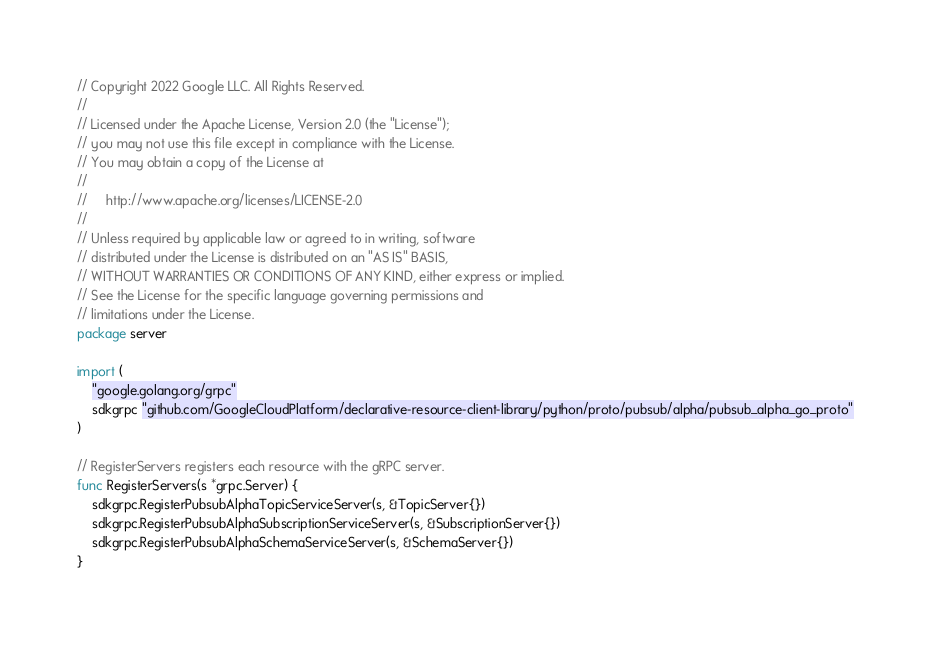Convert code to text. <code><loc_0><loc_0><loc_500><loc_500><_Go_>// Copyright 2022 Google LLC. All Rights Reserved.
// 
// Licensed under the Apache License, Version 2.0 (the "License");
// you may not use this file except in compliance with the License.
// You may obtain a copy of the License at
// 
//     http://www.apache.org/licenses/LICENSE-2.0
// 
// Unless required by applicable law or agreed to in writing, software
// distributed under the License is distributed on an "AS IS" BASIS,
// WITHOUT WARRANTIES OR CONDITIONS OF ANY KIND, either express or implied.
// See the License for the specific language governing permissions and
// limitations under the License.
package server

import (
	"google.golang.org/grpc"
	sdkgrpc "github.com/GoogleCloudPlatform/declarative-resource-client-library/python/proto/pubsub/alpha/pubsub_alpha_go_proto"
)

// RegisterServers registers each resource with the gRPC server.
func RegisterServers(s *grpc.Server) {
	sdkgrpc.RegisterPubsubAlphaTopicServiceServer(s, &TopicServer{})
	sdkgrpc.RegisterPubsubAlphaSubscriptionServiceServer(s, &SubscriptionServer{})
	sdkgrpc.RegisterPubsubAlphaSchemaServiceServer(s, &SchemaServer{})
}
</code> 